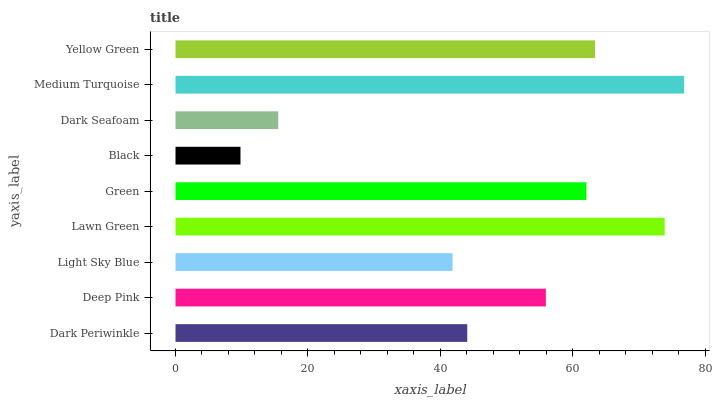Is Black the minimum?
Answer yes or no. Yes. Is Medium Turquoise the maximum?
Answer yes or no. Yes. Is Deep Pink the minimum?
Answer yes or no. No. Is Deep Pink the maximum?
Answer yes or no. No. Is Deep Pink greater than Dark Periwinkle?
Answer yes or no. Yes. Is Dark Periwinkle less than Deep Pink?
Answer yes or no. Yes. Is Dark Periwinkle greater than Deep Pink?
Answer yes or no. No. Is Deep Pink less than Dark Periwinkle?
Answer yes or no. No. Is Deep Pink the high median?
Answer yes or no. Yes. Is Deep Pink the low median?
Answer yes or no. Yes. Is Dark Periwinkle the high median?
Answer yes or no. No. Is Dark Periwinkle the low median?
Answer yes or no. No. 